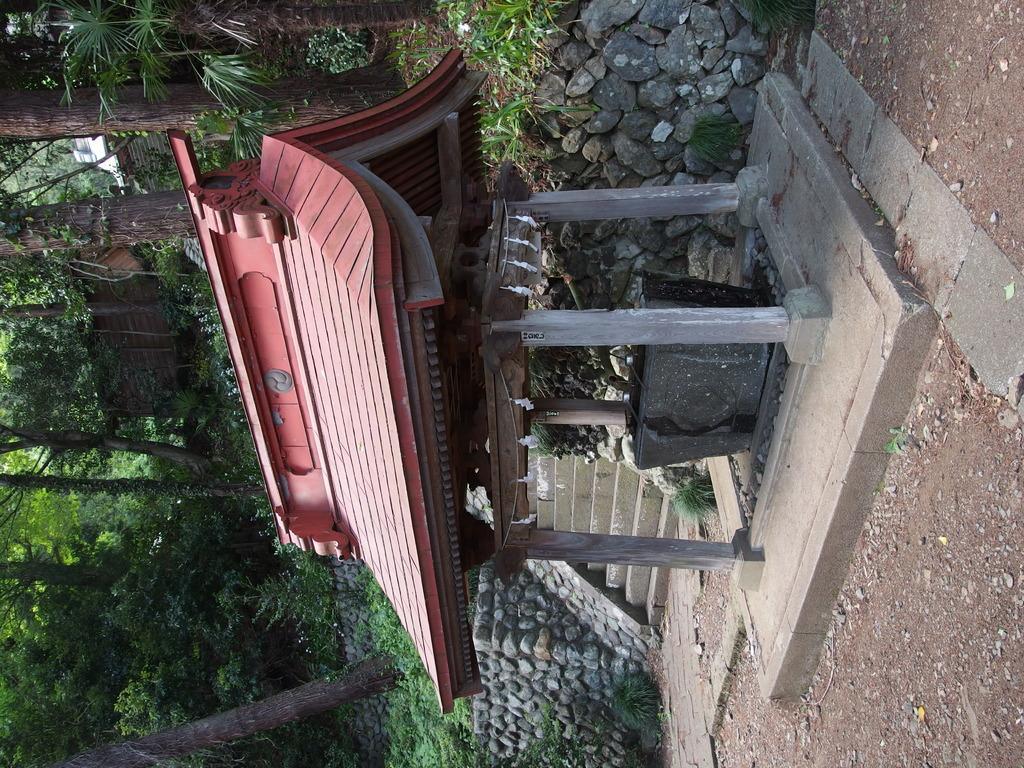In one or two sentences, can you explain what this image depicts? In this image I can see a red colour Chinese shed in the different. In the background I can see grass and number of trees. 